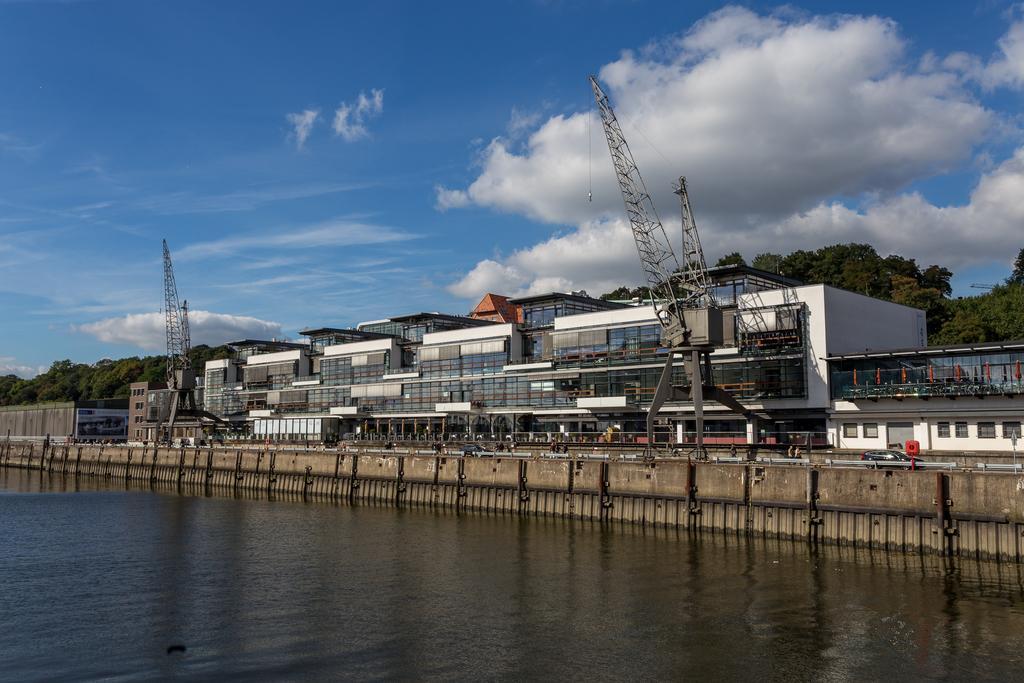In one or two sentences, can you explain what this image depicts? In this picture there is water at the bottom side of the image and there are trees and buildings in the center of the image, there is sky at the top side of the image. 